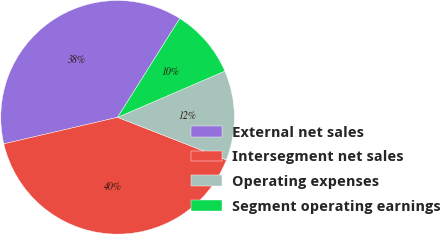Convert chart. <chart><loc_0><loc_0><loc_500><loc_500><pie_chart><fcel>External net sales<fcel>Intersegment net sales<fcel>Operating expenses<fcel>Segment operating earnings<nl><fcel>37.59%<fcel>40.42%<fcel>12.41%<fcel>9.58%<nl></chart> 